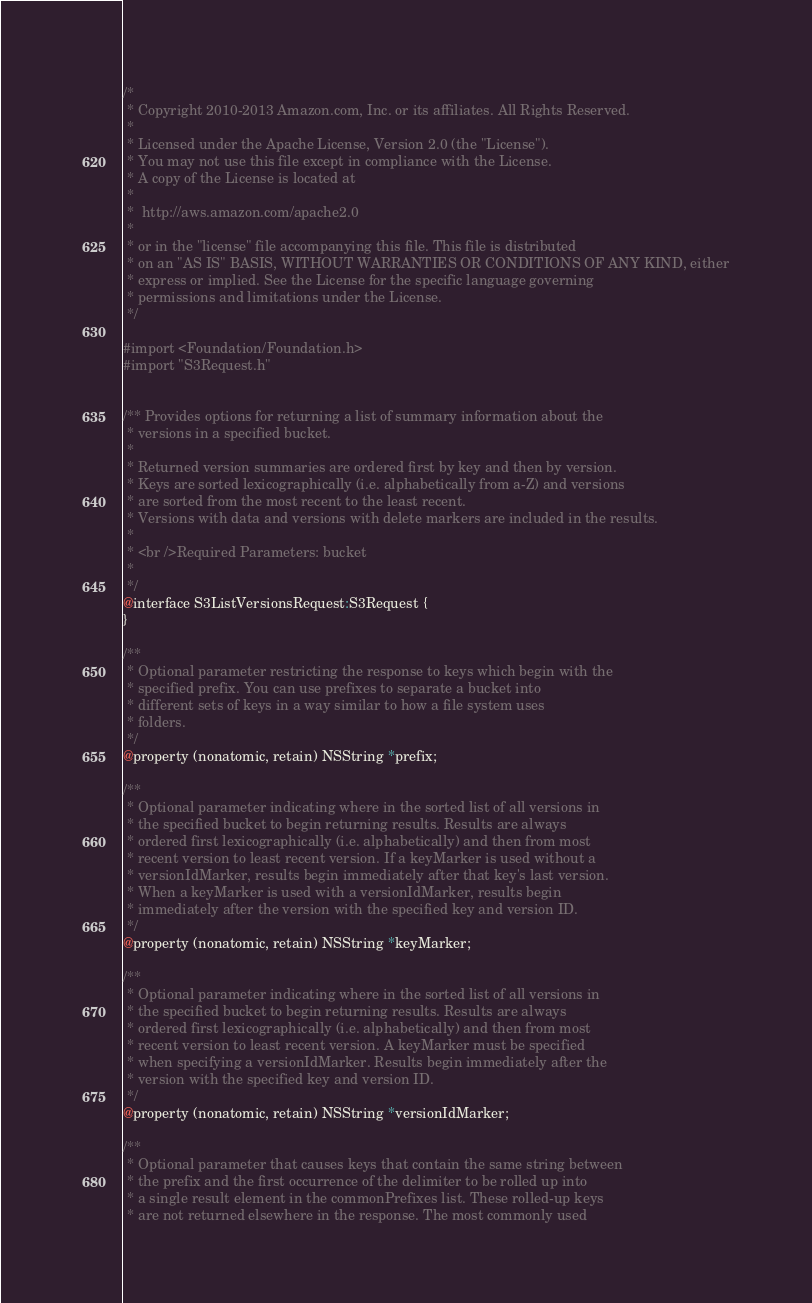Convert code to text. <code><loc_0><loc_0><loc_500><loc_500><_C_>/*
 * Copyright 2010-2013 Amazon.com, Inc. or its affiliates. All Rights Reserved.
 *
 * Licensed under the Apache License, Version 2.0 (the "License").
 * You may not use this file except in compliance with the License.
 * A copy of the License is located at
 *
 *  http://aws.amazon.com/apache2.0
 *
 * or in the "license" file accompanying this file. This file is distributed
 * on an "AS IS" BASIS, WITHOUT WARRANTIES OR CONDITIONS OF ANY KIND, either
 * express or implied. See the License for the specific language governing
 * permissions and limitations under the License.
 */

#import <Foundation/Foundation.h>
#import "S3Request.h"


/** Provides options for returning a list of summary information about the
 * versions in a specified bucket.
 *
 * Returned version summaries are ordered first by key and then by version.
 * Keys are sorted lexicographically (i.e. alphabetically from a-Z) and versions
 * are sorted from the most recent to the least recent.
 * Versions with data and versions with delete markers are included in the results.
 *
 * <br />Required Parameters: bucket
 *
 */
@interface S3ListVersionsRequest:S3Request {
}

/**
 * Optional parameter restricting the response to keys which begin with the
 * specified prefix. You can use prefixes to separate a bucket into
 * different sets of keys in a way similar to how a file system uses
 * folders.
 */
@property (nonatomic, retain) NSString *prefix;

/**
 * Optional parameter indicating where in the sorted list of all versions in
 * the specified bucket to begin returning results. Results are always
 * ordered first lexicographically (i.e. alphabetically) and then from most
 * recent version to least recent version. If a keyMarker is used without a
 * versionIdMarker, results begin immediately after that key's last version.
 * When a keyMarker is used with a versionIdMarker, results begin
 * immediately after the version with the specified key and version ID.
 */
@property (nonatomic, retain) NSString *keyMarker;

/**
 * Optional parameter indicating where in the sorted list of all versions in
 * the specified bucket to begin returning results. Results are always
 * ordered first lexicographically (i.e. alphabetically) and then from most
 * recent version to least recent version. A keyMarker must be specified
 * when specifying a versionIdMarker. Results begin immediately after the
 * version with the specified key and version ID.
 */
@property (nonatomic, retain) NSString *versionIdMarker;

/**
 * Optional parameter that causes keys that contain the same string between
 * the prefix and the first occurrence of the delimiter to be rolled up into
 * a single result element in the commonPrefixes list. These rolled-up keys
 * are not returned elsewhere in the response. The most commonly used</code> 